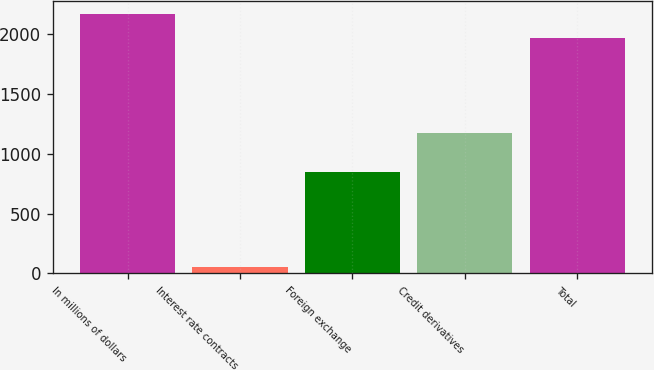Convert chart. <chart><loc_0><loc_0><loc_500><loc_500><bar_chart><fcel>In millions of dollars<fcel>Interest rate contracts<fcel>Foreign exchange<fcel>Credit derivatives<fcel>Total<nl><fcel>2166.5<fcel>51<fcel>847<fcel>1174<fcel>1970<nl></chart> 